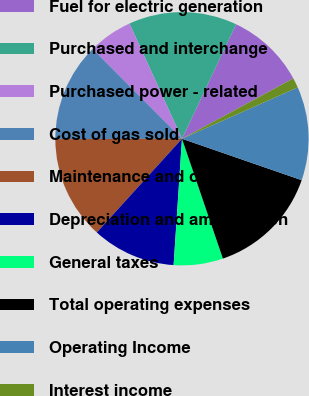Convert chart. <chart><loc_0><loc_0><loc_500><loc_500><pie_chart><fcel>Fuel for electric generation<fcel>Purchased and interchange<fcel>Purchased power - related<fcel>Cost of gas sold<fcel>Maintenance and other<fcel>Depreciation and amortization<fcel>General taxes<fcel>Total operating expenses<fcel>Operating Income<fcel>Interest income<nl><fcel>10.06%<fcel>13.84%<fcel>5.66%<fcel>12.58%<fcel>13.21%<fcel>10.69%<fcel>6.29%<fcel>14.46%<fcel>11.95%<fcel>1.26%<nl></chart> 